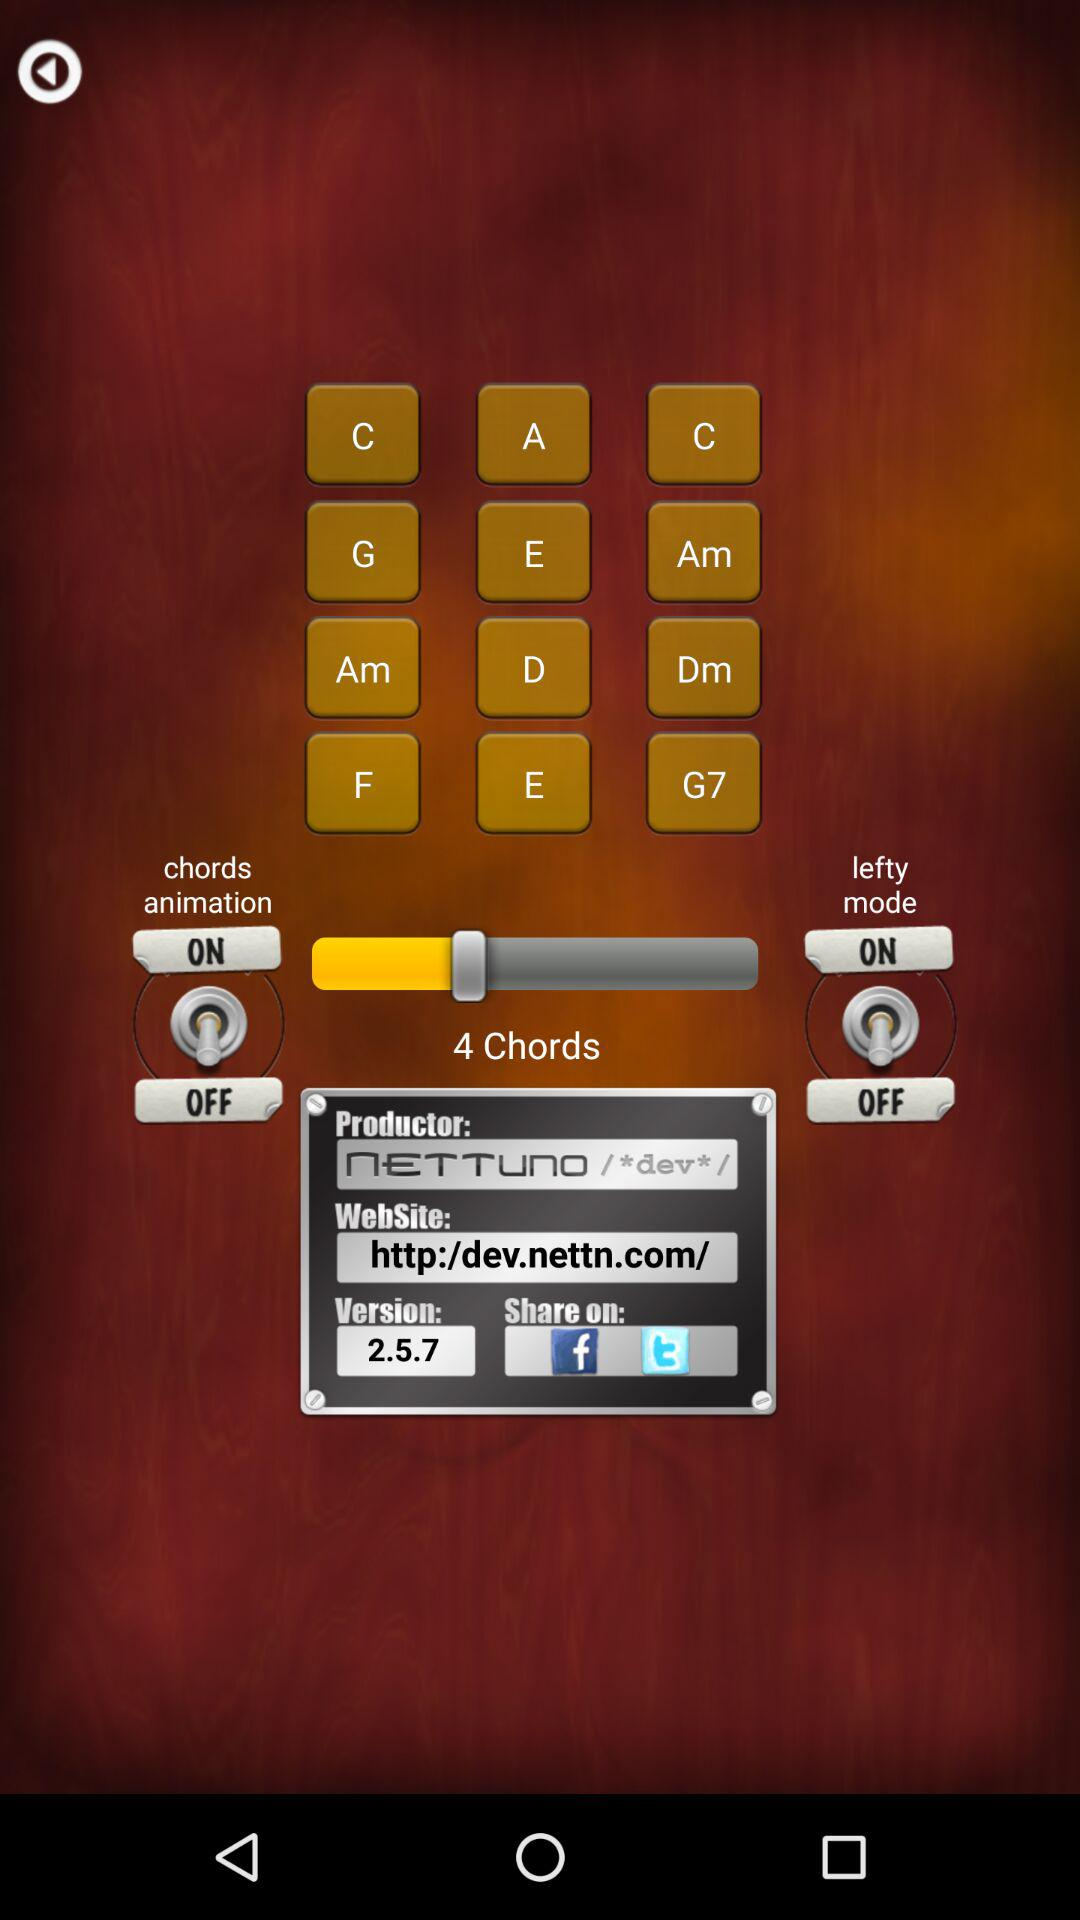How many chords are available? There are 4 chords available. 